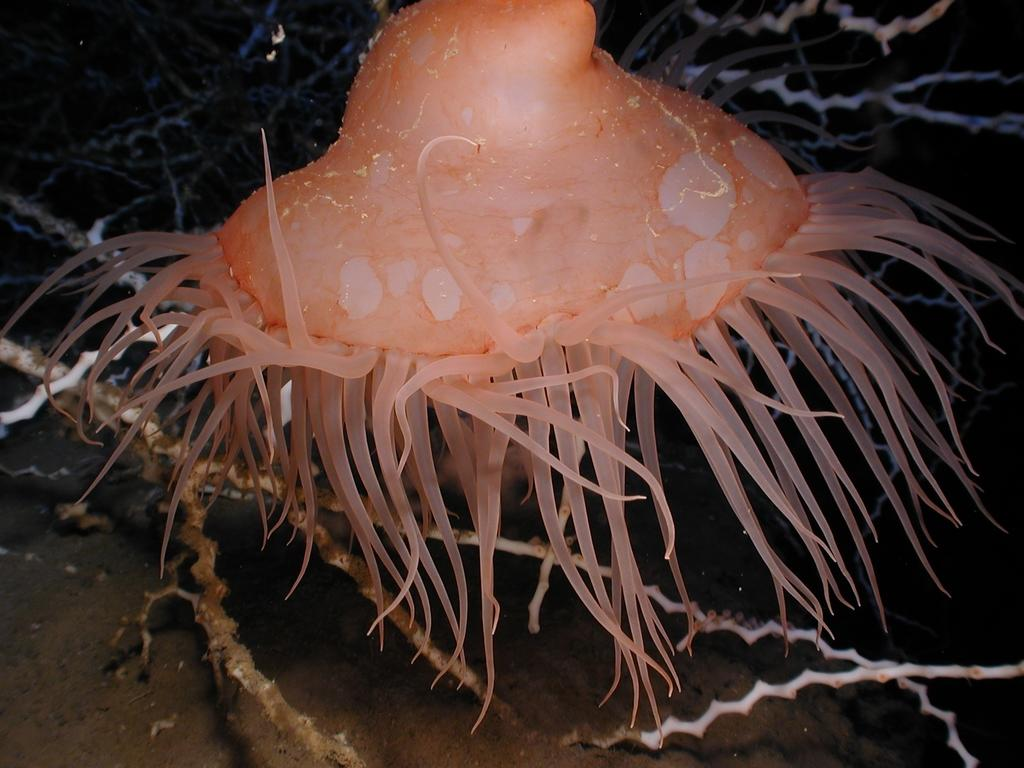What type of animal is in the image? There is a jellyfish in the image. Where is the jellyfish located? The jellyfish is in the water. What type of hill can be seen in the background of the image? There is no hill present in the image; it features a jellyfish in the water. 